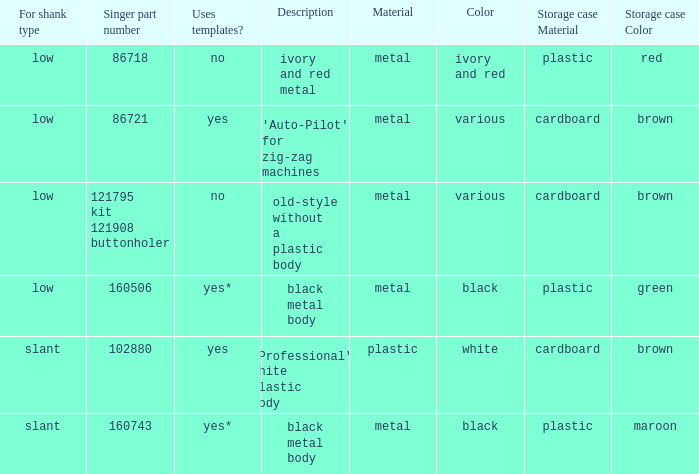What various descriptions can be provided for a buttonholer with a cardboard storage box and a low shank type? 'Auto-Pilot' for zig-zag machines, old-style without a plastic body. 